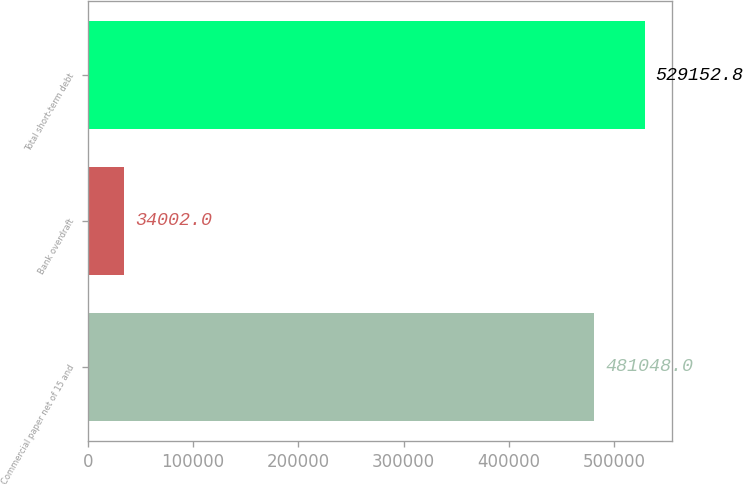<chart> <loc_0><loc_0><loc_500><loc_500><bar_chart><fcel>Commercial paper net of 15 and<fcel>Bank overdraft<fcel>Total short-term debt<nl><fcel>481048<fcel>34002<fcel>529153<nl></chart> 